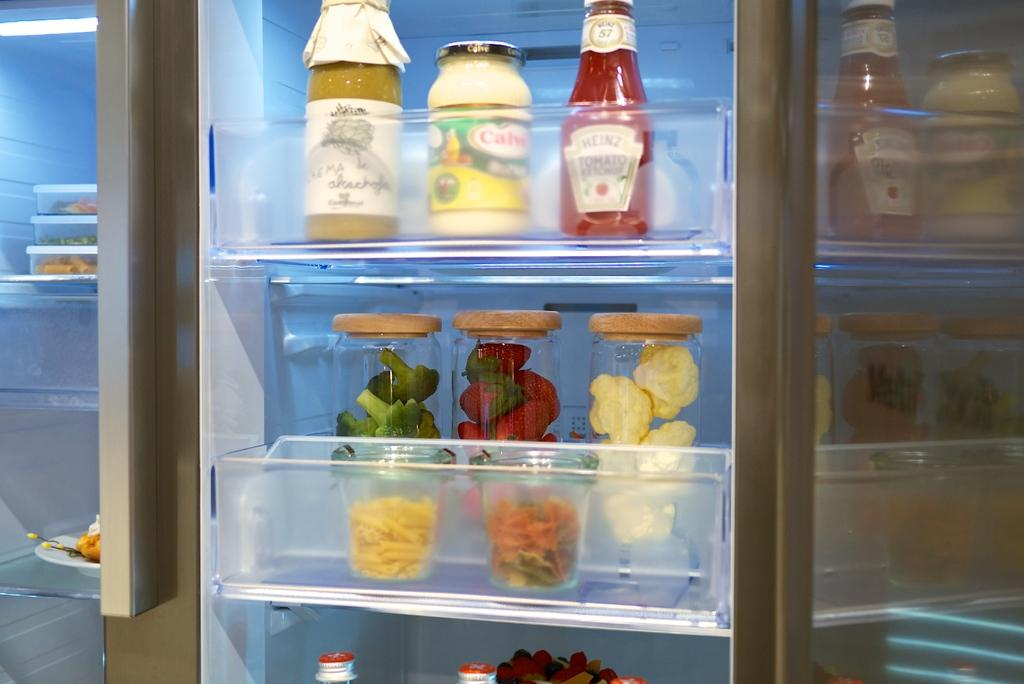What type of appliance is visible in the image? There is a refrigerator in the image. What can be found inside the refrigerator? There are many bottles with food items in the refrigerator. What is the tax rate on the food items in the image? There is no information about tax rates in the image, as it only shows a refrigerator with bottles containing food items. 